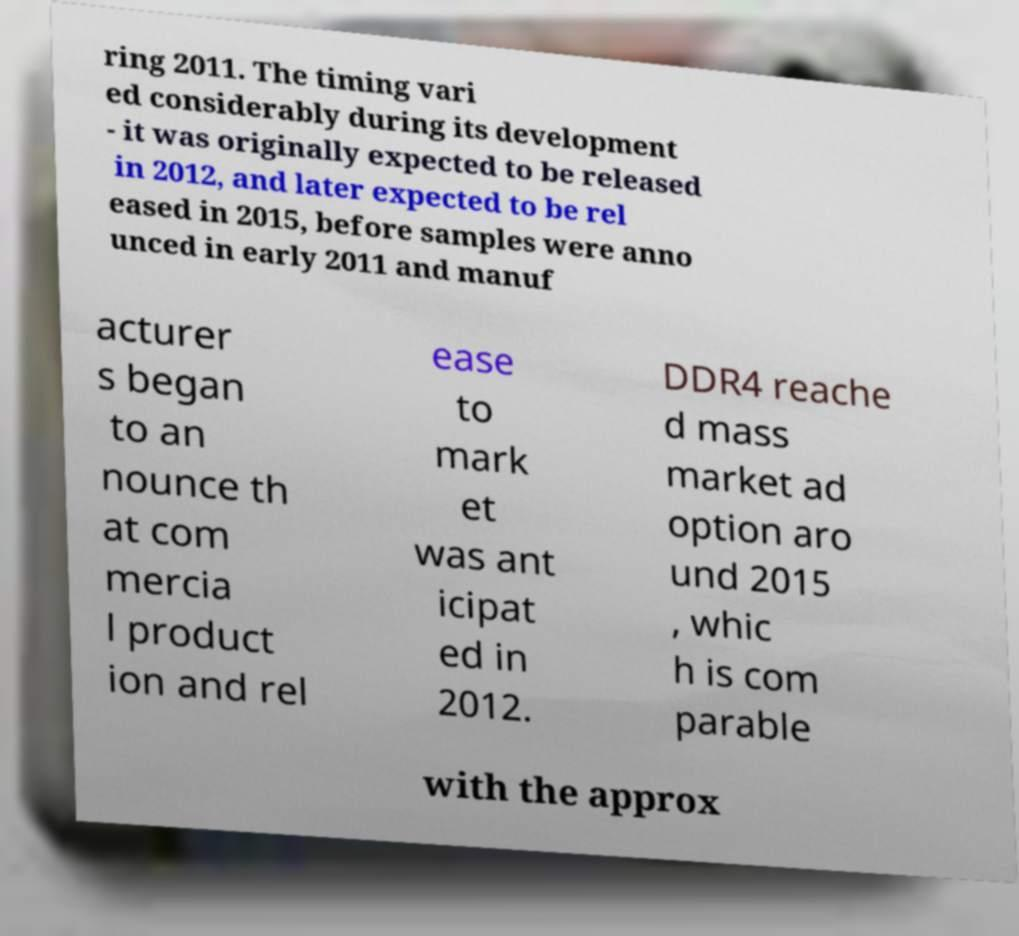Please read and relay the text visible in this image. What does it say? ring 2011. The timing vari ed considerably during its development - it was originally expected to be released in 2012, and later expected to be rel eased in 2015, before samples were anno unced in early 2011 and manuf acturer s began to an nounce th at com mercia l product ion and rel ease to mark et was ant icipat ed in 2012. DDR4 reache d mass market ad option aro und 2015 , whic h is com parable with the approx 